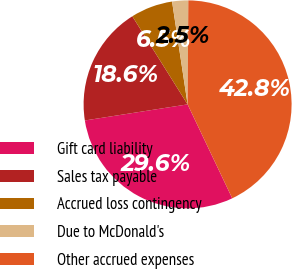<chart> <loc_0><loc_0><loc_500><loc_500><pie_chart><fcel>Gift card liability<fcel>Sales tax payable<fcel>Accrued loss contingency<fcel>Due to McDonald's<fcel>Other accrued expenses<nl><fcel>29.59%<fcel>18.56%<fcel>6.53%<fcel>2.5%<fcel>42.83%<nl></chart> 